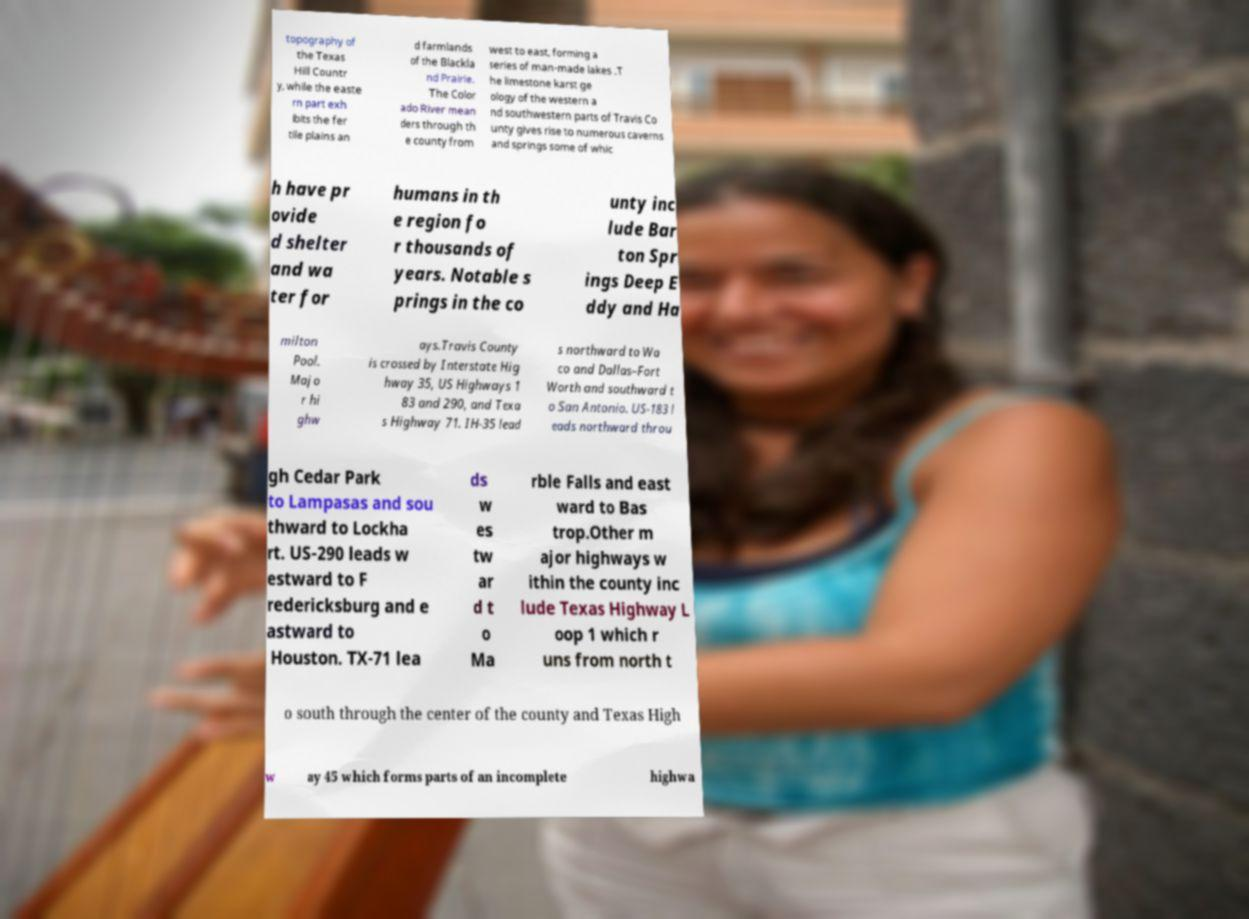Please read and relay the text visible in this image. What does it say? topography of the Texas Hill Countr y, while the easte rn part exh ibits the fer tile plains an d farmlands of the Blackla nd Prairie. The Color ado River mean ders through th e county from west to east, forming a series of man-made lakes .T he limestone karst ge ology of the western a nd southwestern parts of Travis Co unty gives rise to numerous caverns and springs some of whic h have pr ovide d shelter and wa ter for humans in th e region fo r thousands of years. Notable s prings in the co unty inc lude Bar ton Spr ings Deep E ddy and Ha milton Pool. Majo r hi ghw ays.Travis County is crossed by Interstate Hig hway 35, US Highways 1 83 and 290, and Texa s Highway 71. IH-35 lead s northward to Wa co and Dallas–Fort Worth and southward t o San Antonio. US-183 l eads northward throu gh Cedar Park to Lampasas and sou thward to Lockha rt. US-290 leads w estward to F redericksburg and e astward to Houston. TX-71 lea ds w es tw ar d t o Ma rble Falls and east ward to Bas trop.Other m ajor highways w ithin the county inc lude Texas Highway L oop 1 which r uns from north t o south through the center of the county and Texas High w ay 45 which forms parts of an incomplete highwa 